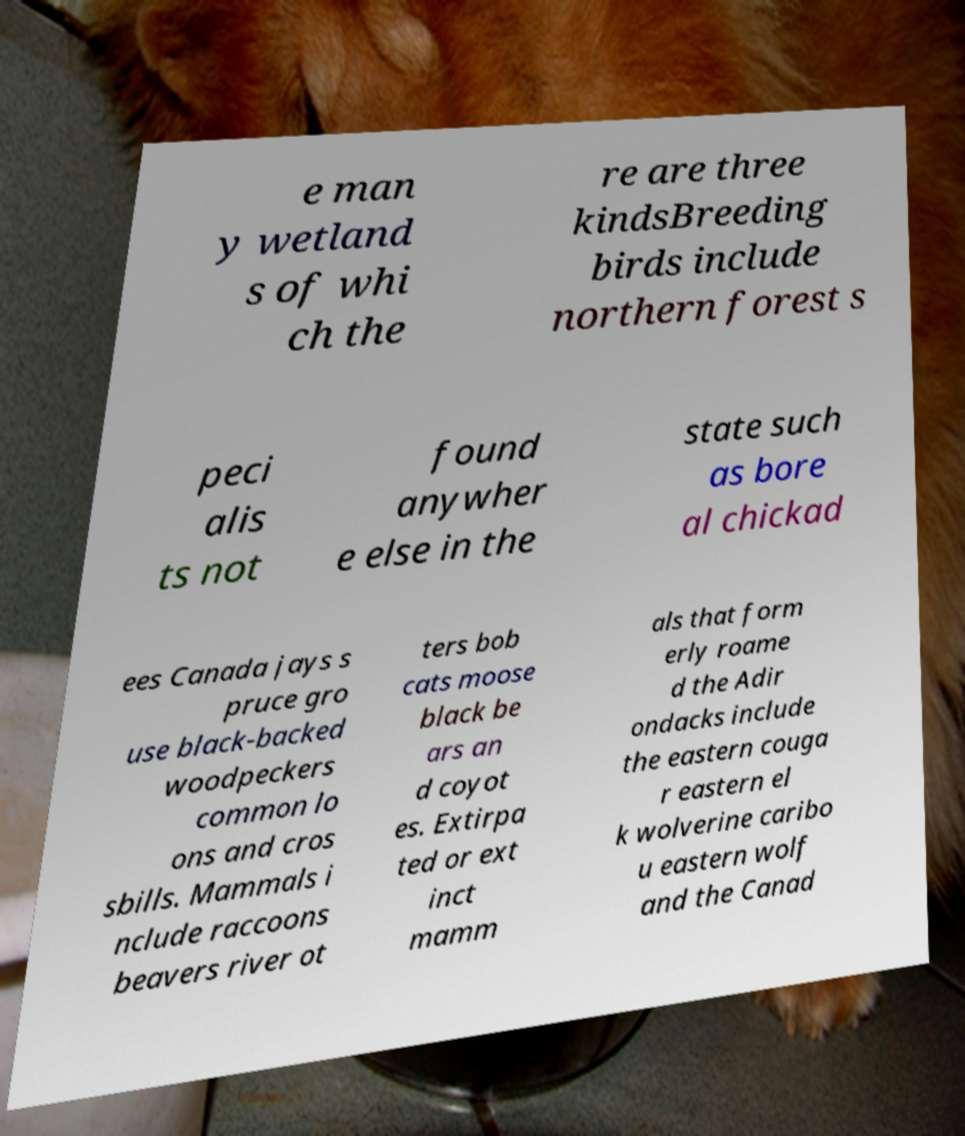Please identify and transcribe the text found in this image. e man y wetland s of whi ch the re are three kindsBreeding birds include northern forest s peci alis ts not found anywher e else in the state such as bore al chickad ees Canada jays s pruce gro use black-backed woodpeckers common lo ons and cros sbills. Mammals i nclude raccoons beavers river ot ters bob cats moose black be ars an d coyot es. Extirpa ted or ext inct mamm als that form erly roame d the Adir ondacks include the eastern couga r eastern el k wolverine caribo u eastern wolf and the Canad 